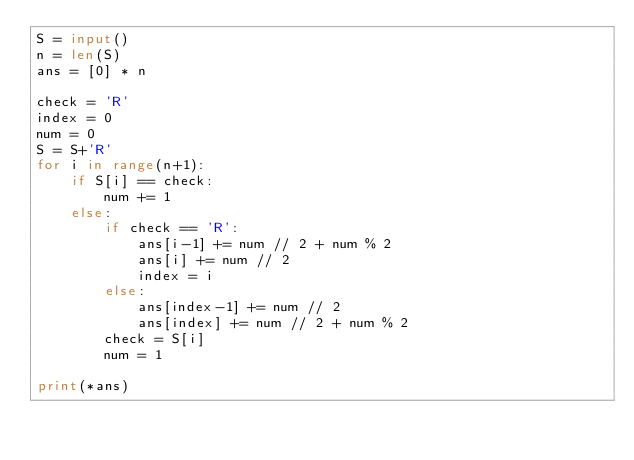<code> <loc_0><loc_0><loc_500><loc_500><_Python_>S = input()
n = len(S)
ans = [0] * n

check = 'R'
index = 0
num = 0
S = S+'R'
for i in range(n+1):
    if S[i] == check:
        num += 1
    else:
        if check == 'R':
            ans[i-1] += num // 2 + num % 2
            ans[i] += num // 2
            index = i
        else:
            ans[index-1] += num // 2
            ans[index] += num // 2 + num % 2
        check = S[i]
        num = 1

print(*ans)
</code> 